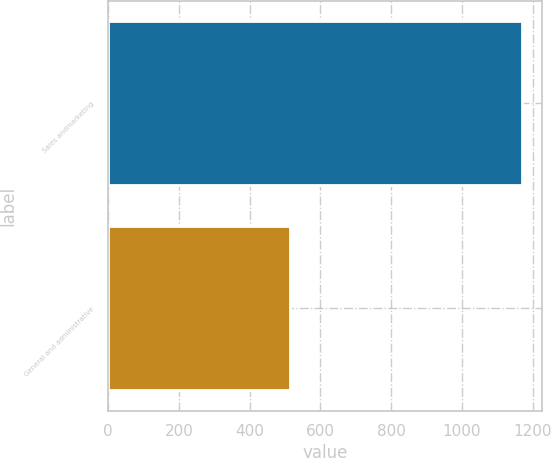<chart> <loc_0><loc_0><loc_500><loc_500><bar_chart><fcel>Sales andmarketing<fcel>General and administrative<nl><fcel>1169<fcel>514<nl></chart> 